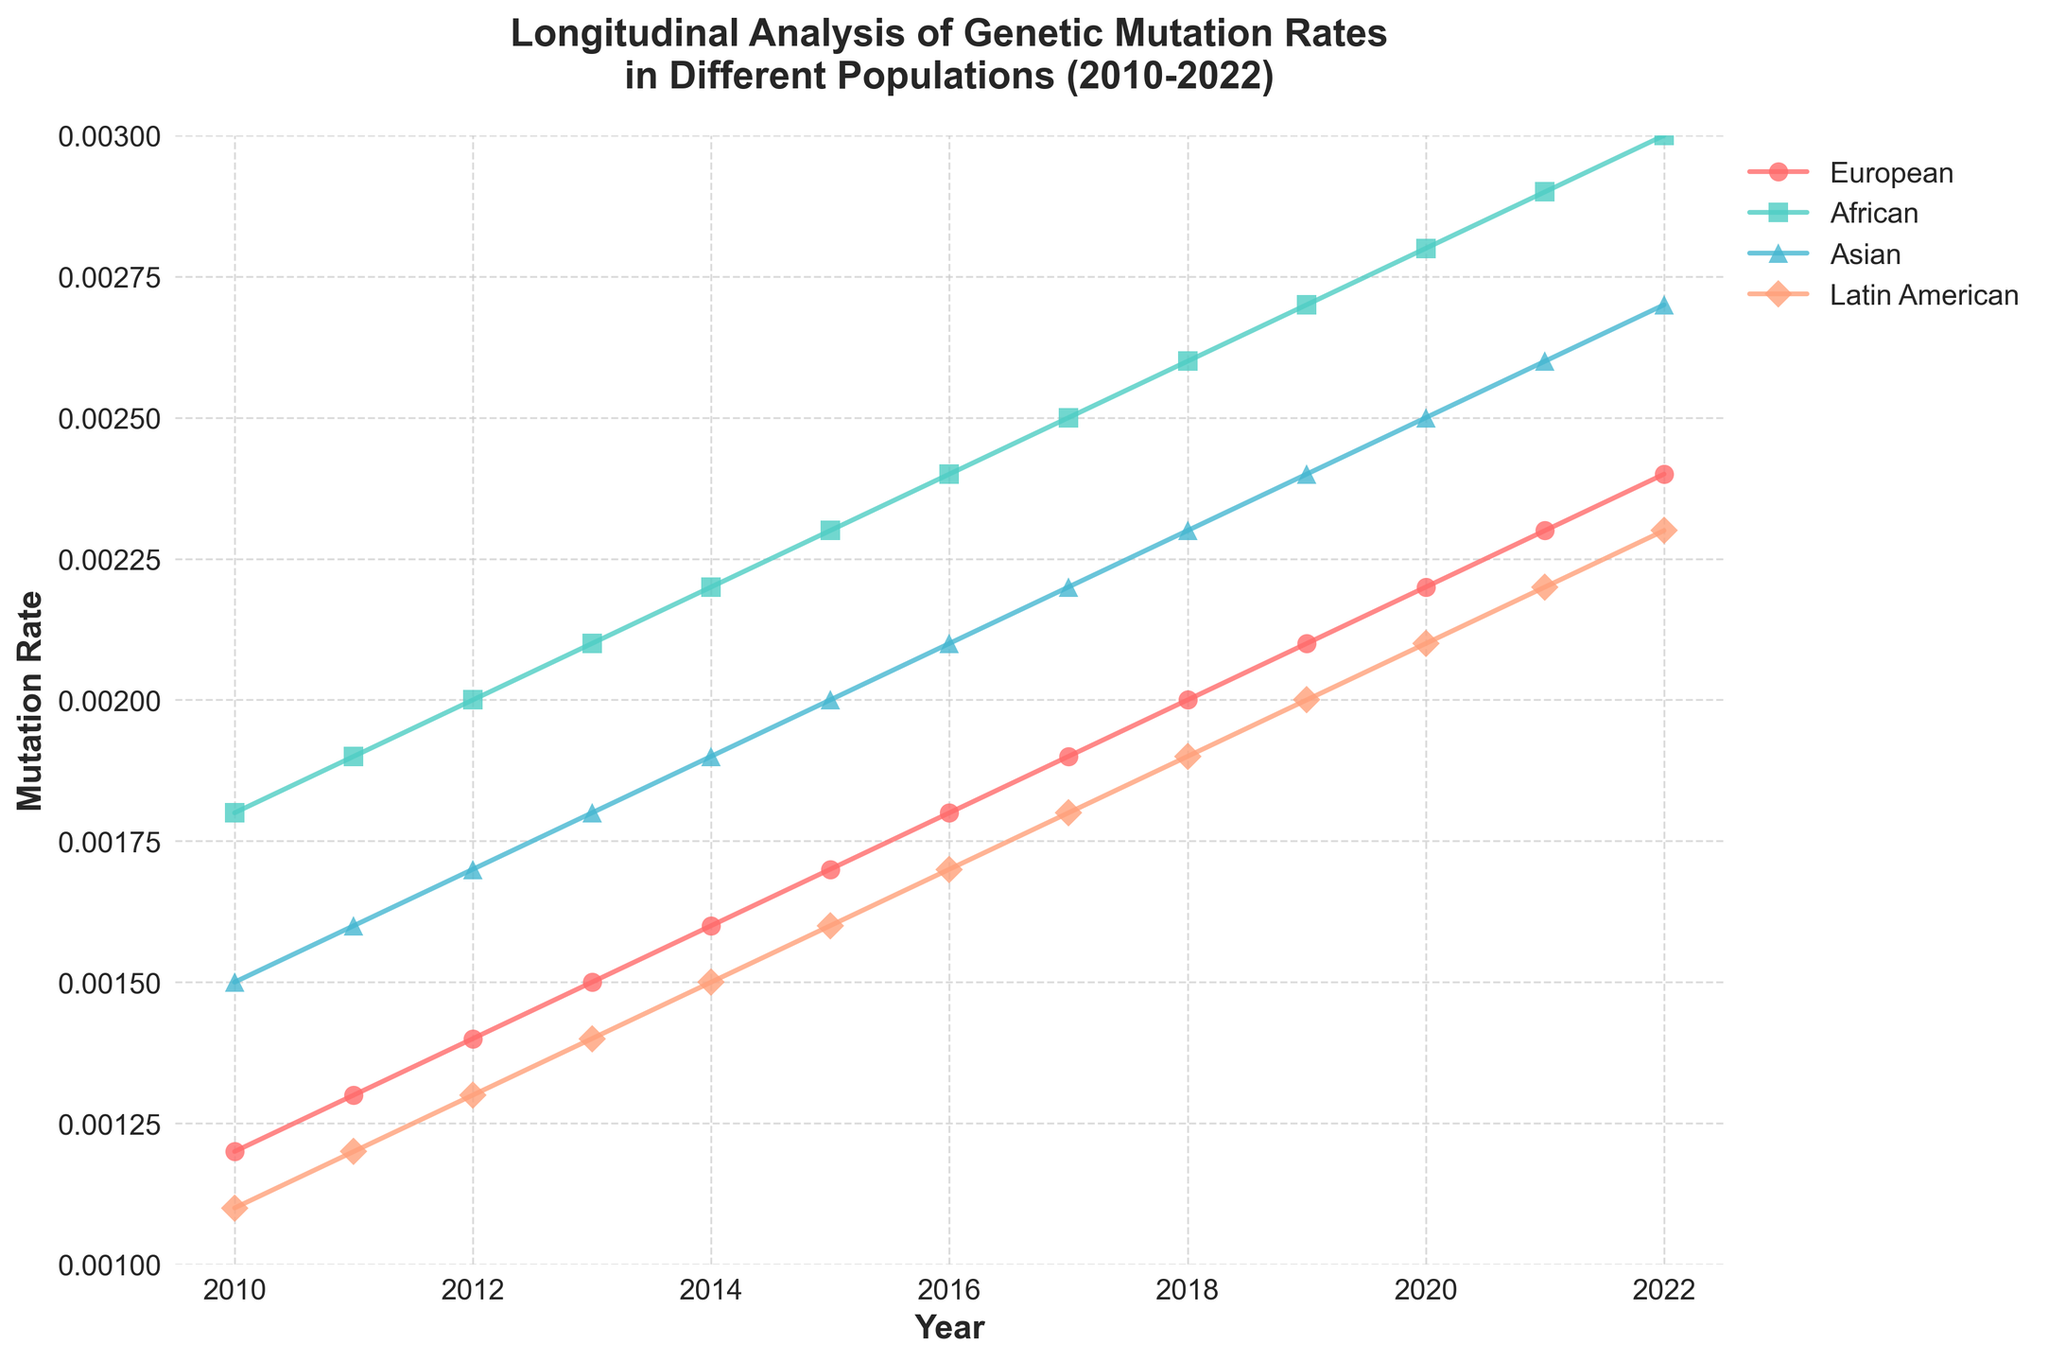What is the title of the figure? The title of the figure is written at the top center of the plot. It gives the context of the data that is being analyzed and presented.
Answer: Longitudinal Analysis of Genetic Mutation Rates in Different Populations (2010-2022) What are the populations being compared in the plot? The populations being compared in the plot are indicated by different colors and markers in the legend on the right of the plot.
Answer: European, African, Asian, Latin American What is the x-axis representing in the figure? The x-axis in the figure represents the year, as indicated by the label on the axis itself. This provides the time series aspect of the plot.
Answer: Year Which population experienced the highest increase in mutation rate from 2010 to 2022? Looking at the lines that represent each population, we can see that the African population has the steepest upward trend from 2010 to 2022.
Answer: African What was the mutation rate for the European population in 2015? Locate the marker for the European population at the year 2015 and read the corresponding value off the y-axis.
Answer: 0.0017 Between 2010 and 2015, which population had the smallest increase in mutation rates? Calculate the difference in mutation rates between 2010 and 2015 for each population by comparing the y-values for these years, and identify the smallest increase.
Answer: Latin American In what year did the Asian population's mutation rate first exceed 0.0020? Follow the trend line for the Asian population and identify the first year where it crosses the 0.0020 mark on the y-axis.
Answer: 2016 What is the overall trend in mutation rates for all populations from 2010 to 2022? Observing the lines representing each population, we can see that all populations show an upward trend in mutation rates over time.
Answer: Increasing By how much did the mutation rate for the African population increase from 2011 to 2020? Calculate the difference between the mutation rates for the African population in 2011 and 2020 by subtracting the y-value in 2011 from the y-value in 2020.
Answer: 0.0009 